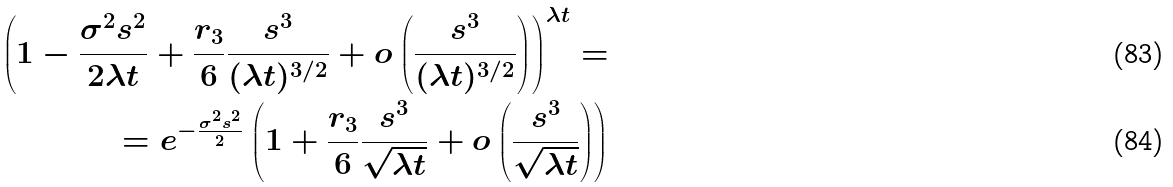Convert formula to latex. <formula><loc_0><loc_0><loc_500><loc_500>\left ( 1 - \frac { \sigma ^ { 2 } s ^ { 2 } } { 2 \lambda t } + \frac { r _ { 3 } } { 6 } \frac { s ^ { 3 } } { ( \lambda t ) ^ { 3 / 2 } } + o \left ( \frac { s ^ { 3 } } { ( \lambda t ) ^ { 3 / 2 } } \right ) \right ) ^ { \lambda t } = \\ = e ^ { - \frac { \sigma ^ { 2 } s ^ { 2 } } { 2 } } \left ( 1 + \frac { r _ { 3 } } { 6 } \frac { s ^ { 3 } } { \sqrt { \lambda t } } + o \left ( \frac { s ^ { 3 } } { \sqrt { \lambda t } } \right ) \right )</formula> 